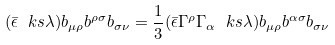Convert formula to latex. <formula><loc_0><loc_0><loc_500><loc_500>( \bar { \epsilon } \ k s \lambda ) b _ { \mu \rho } b ^ { \rho \sigma } b _ { \sigma \nu } = \frac { 1 } { 3 } ( \bar { \epsilon } \Gamma ^ { \rho } \Gamma _ { \alpha } \ k s \lambda ) b _ { \mu \rho } b ^ { \alpha \sigma } b _ { \sigma \nu }</formula> 